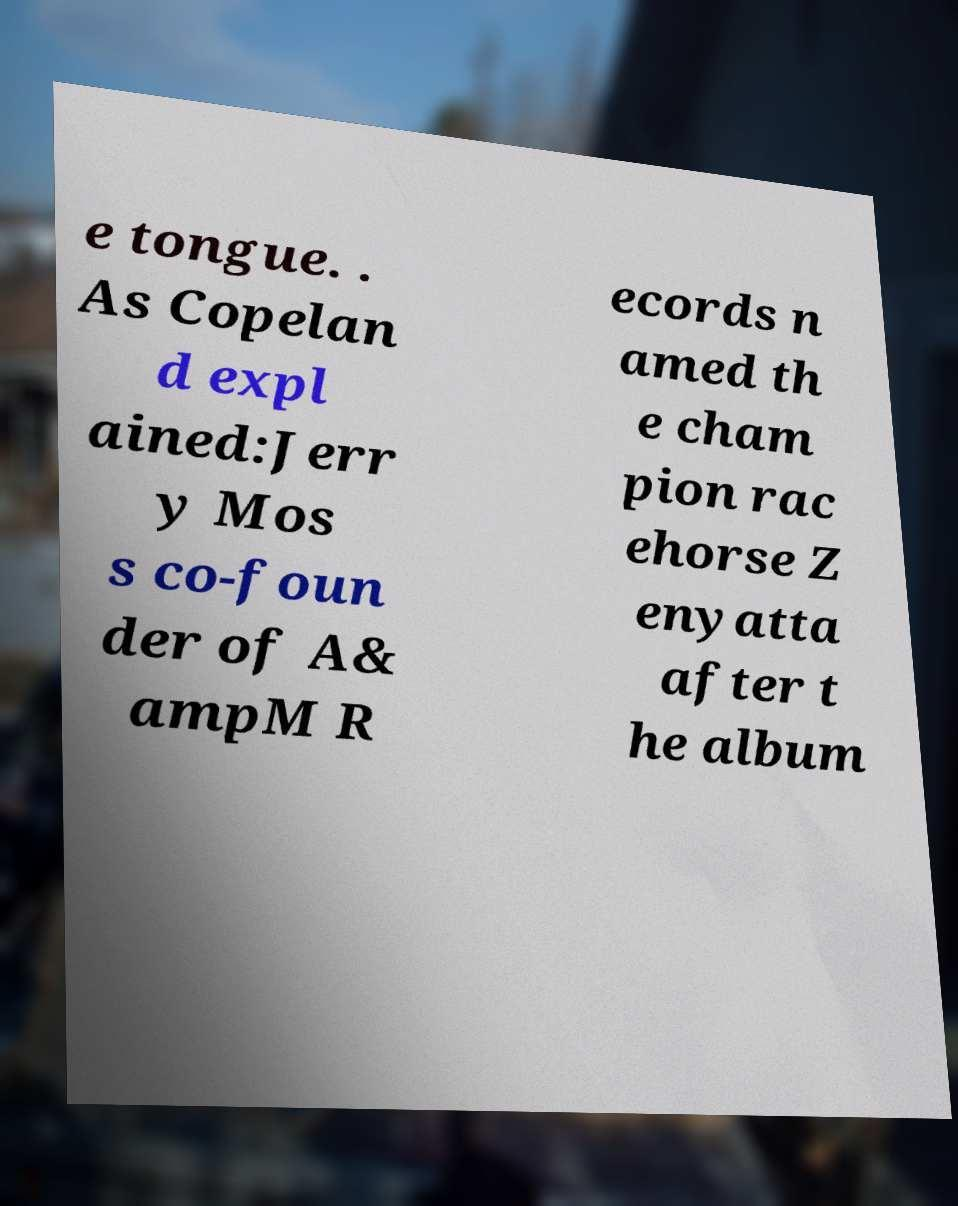For documentation purposes, I need the text within this image transcribed. Could you provide that? e tongue. . As Copelan d expl ained:Jerr y Mos s co-foun der of A& ampM R ecords n amed th e cham pion rac ehorse Z enyatta after t he album 